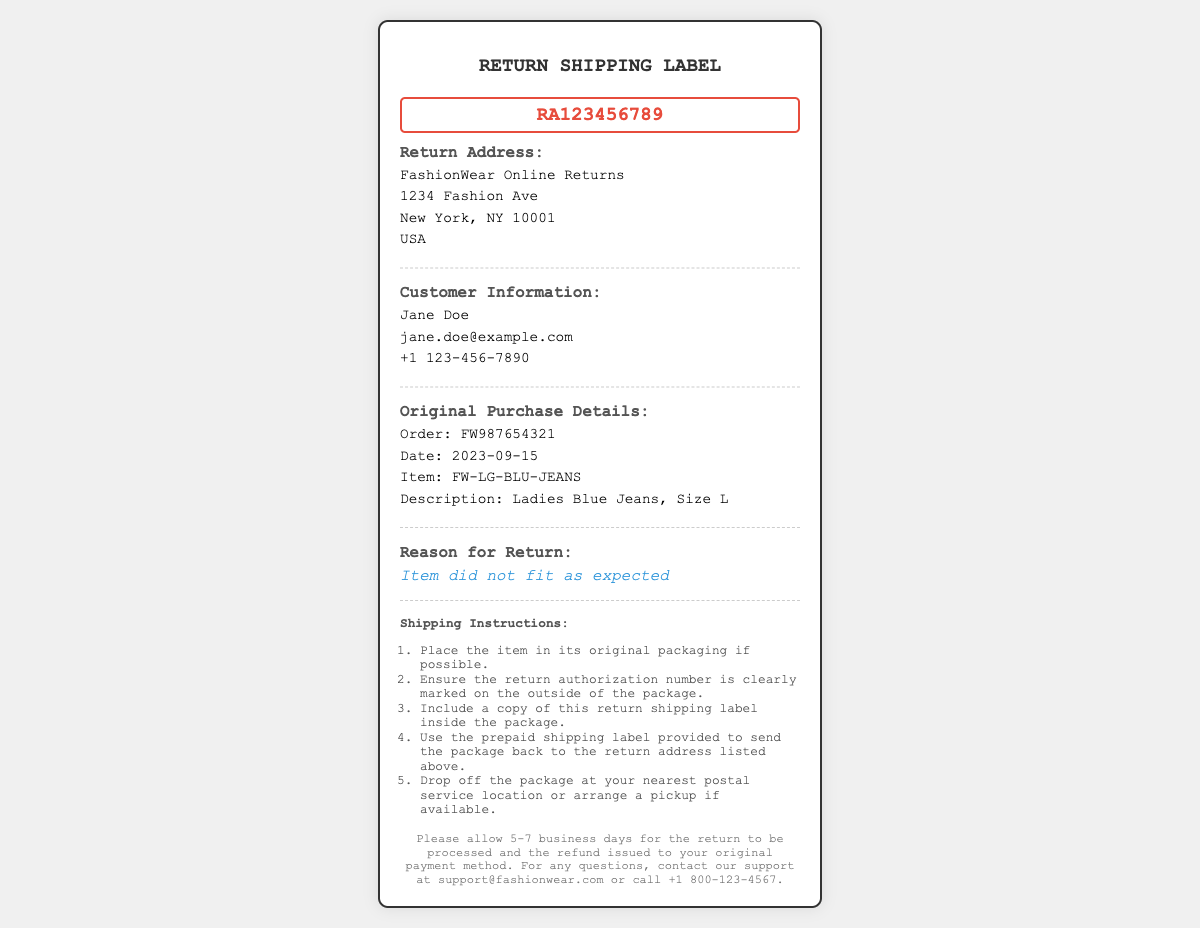What is the return authorization number? The return authorization number is displayed prominently in the document, which is RA123456789.
Answer: RA123456789 What is the return address? The return address is provided in a designated section and is FashionWear Online Returns, 1234 Fashion Ave, New York, NY 10001, USA.
Answer: FashionWear Online Returns, 1234 Fashion Ave, New York, NY 10001, USA Who is the customer? The customer’s information is found under the Customer Information section, where the name Jane Doe is provided.
Answer: Jane Doe What was the order date? The order date can be found in the Original Purchase Details section, which is 2023-09-15.
Answer: 2023-09-15 What is the reason for the return? The reason for the return is explicitly stated as "Item did not fit as expected."
Answer: Item did not fit as expected What instructions should be followed for shipping? The Shipping Instructions section lists multiple steps, one of which is to ensure the return authorization number is clearly marked on the outside of the package.
Answer: Ensure the return authorization number is clearly marked on the outside of the package What item is being returned? The item being returned is detailed in the Original Purchase Details section, identified as "Ladies Blue Jeans, Size L."
Answer: Ladies Blue Jeans, Size L How long will the return processing take? Information towards the end of the document notes the return will be processed in 5-7 business days.
Answer: 5-7 business days What is the email contact for support? The support email address is listed at the bottom of the document as support@fashionwear.com.
Answer: support@fashionwear.com 